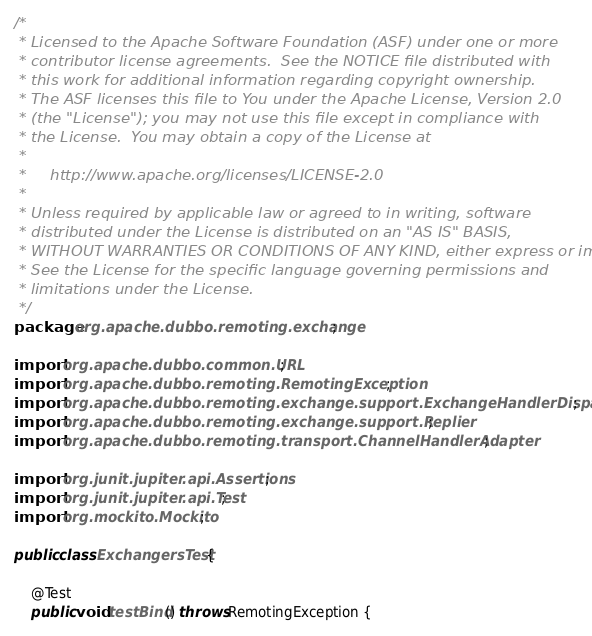Convert code to text. <code><loc_0><loc_0><loc_500><loc_500><_Java_>/*
 * Licensed to the Apache Software Foundation (ASF) under one or more
 * contributor license agreements.  See the NOTICE file distributed with
 * this work for additional information regarding copyright ownership.
 * The ASF licenses this file to You under the Apache License, Version 2.0
 * (the "License"); you may not use this file except in compliance with
 * the License.  You may obtain a copy of the License at
 *
 *     http://www.apache.org/licenses/LICENSE-2.0
 *
 * Unless required by applicable law or agreed to in writing, software
 * distributed under the License is distributed on an "AS IS" BASIS,
 * WITHOUT WARRANTIES OR CONDITIONS OF ANY KIND, either express or implied.
 * See the License for the specific language governing permissions and
 * limitations under the License.
 */
package org.apache.dubbo.remoting.exchange;

import org.apache.dubbo.common.URL;
import org.apache.dubbo.remoting.RemotingException;
import org.apache.dubbo.remoting.exchange.support.ExchangeHandlerDispatcher;
import org.apache.dubbo.remoting.exchange.support.Replier;
import org.apache.dubbo.remoting.transport.ChannelHandlerAdapter;

import org.junit.jupiter.api.Assertions;
import org.junit.jupiter.api.Test;
import org.mockito.Mockito;

public class ExchangersTest {

    @Test
    public void testBind() throws RemotingException {</code> 